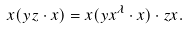Convert formula to latex. <formula><loc_0><loc_0><loc_500><loc_500>x ( y z \cdot x ) = x ( y x ^ { \lambda } \cdot x ) \cdot z x .</formula> 